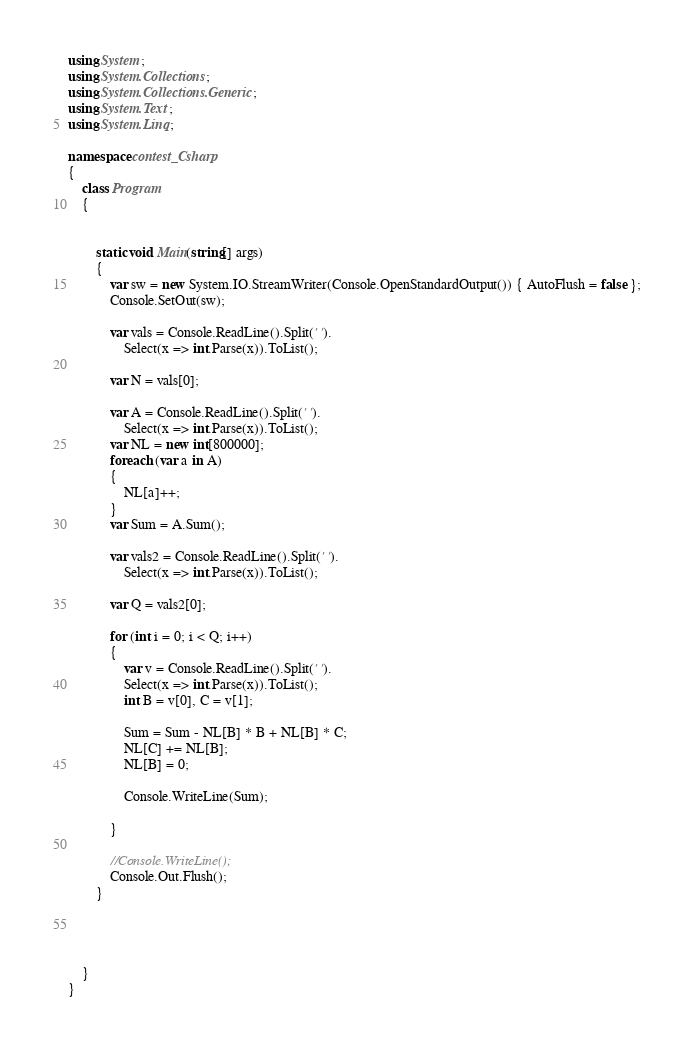<code> <loc_0><loc_0><loc_500><loc_500><_C#_>using System;
using System.Collections;
using System.Collections.Generic;
using System.Text;
using System.Linq;

namespace contest_Csharp
{
    class Program
    {


        static void Main(string[] args)
        {
            var sw = new System.IO.StreamWriter(Console.OpenStandardOutput()) { AutoFlush = false };
            Console.SetOut(sw);

            var vals = Console.ReadLine().Split(' ').
                Select(x => int.Parse(x)).ToList();

            var N = vals[0];

            var A = Console.ReadLine().Split(' ').
                Select(x => int.Parse(x)).ToList();
            var NL = new int[800000];
            foreach (var a in A)
            {
                NL[a]++;
            }
            var Sum = A.Sum();

            var vals2 = Console.ReadLine().Split(' ').
                Select(x => int.Parse(x)).ToList();

            var Q = vals2[0];

            for (int i = 0; i < Q; i++)
            {
                var v = Console.ReadLine().Split(' ').
                Select(x => int.Parse(x)).ToList();
                int B = v[0], C = v[1];

                Sum = Sum - NL[B] * B + NL[B] * C;
                NL[C] += NL[B];
                NL[B] = 0;

                Console.WriteLine(Sum);

            }

            //Console.WriteLine();
            Console.Out.Flush();
        }




    }
}


</code> 